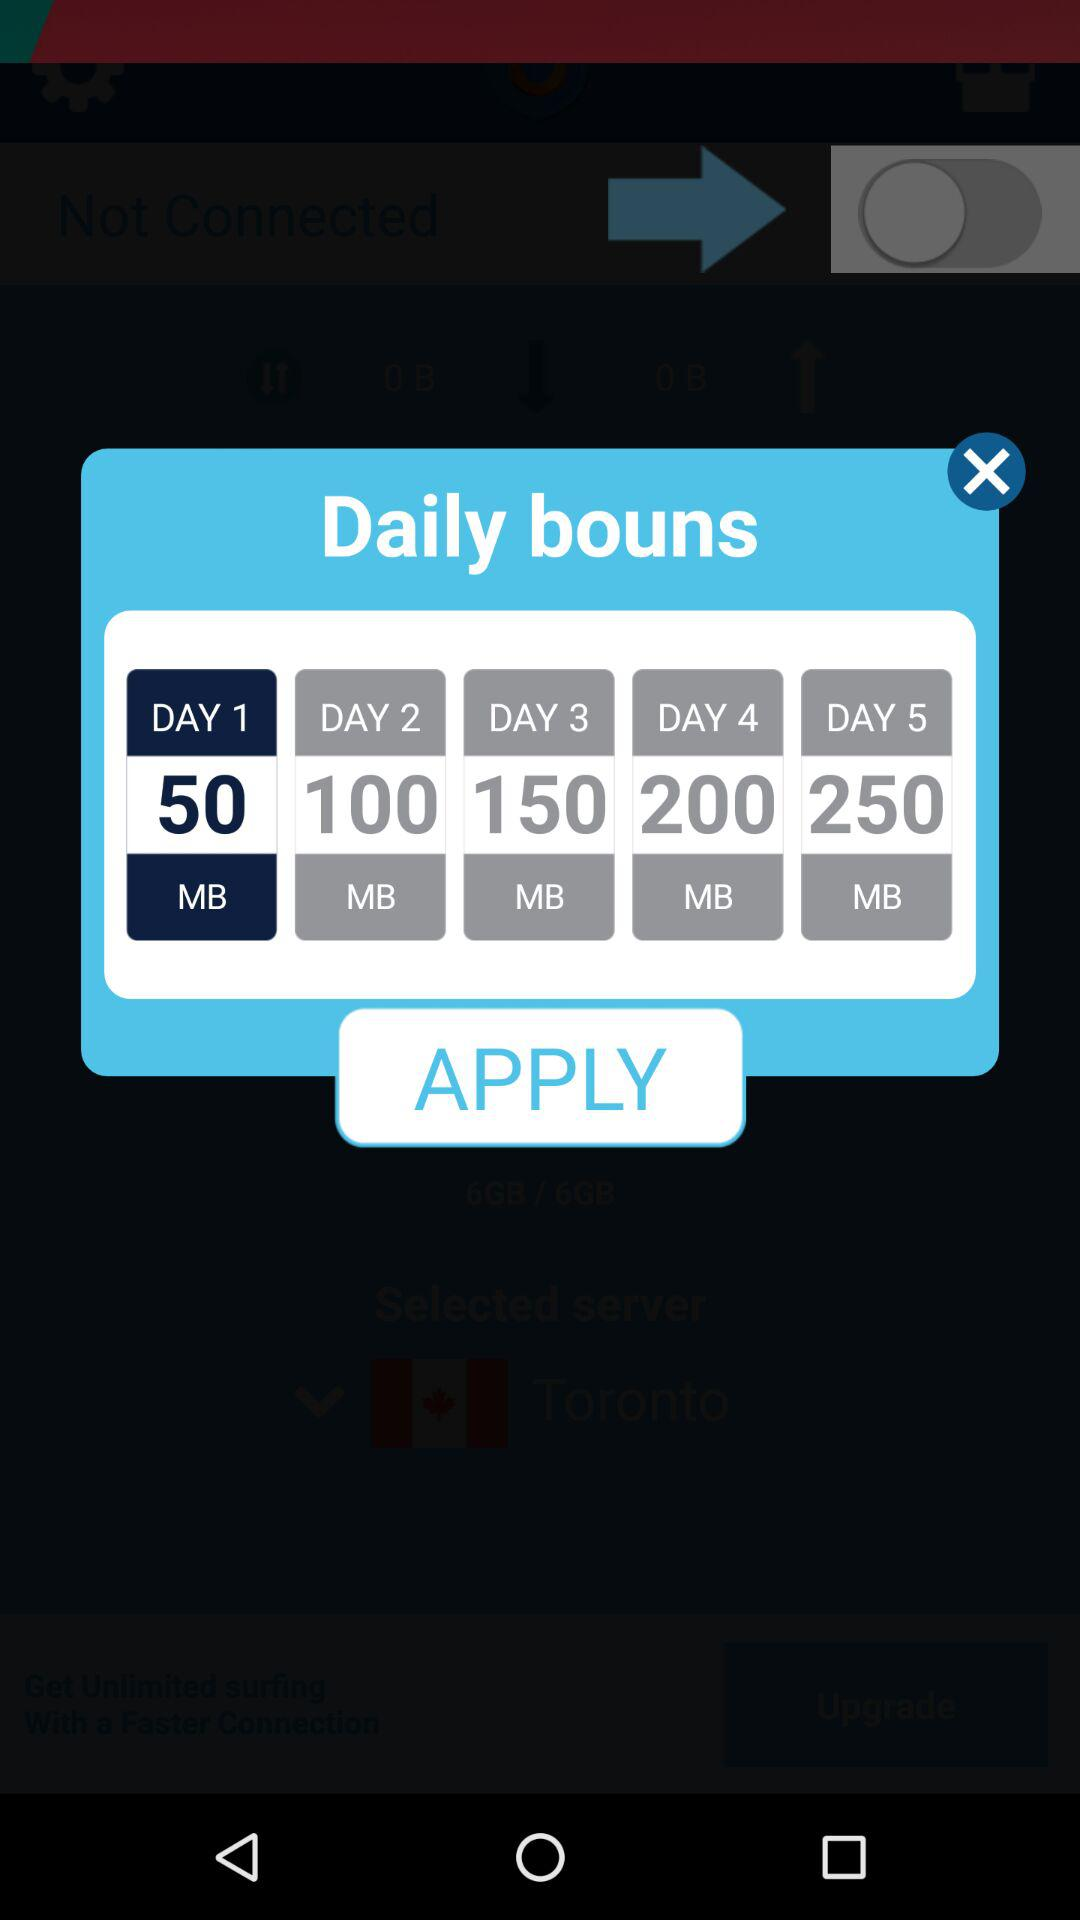How many MB of data are there for the fifth day of the daily bonus? There are 250 MB of data for the fifth day of the daily bonus. 